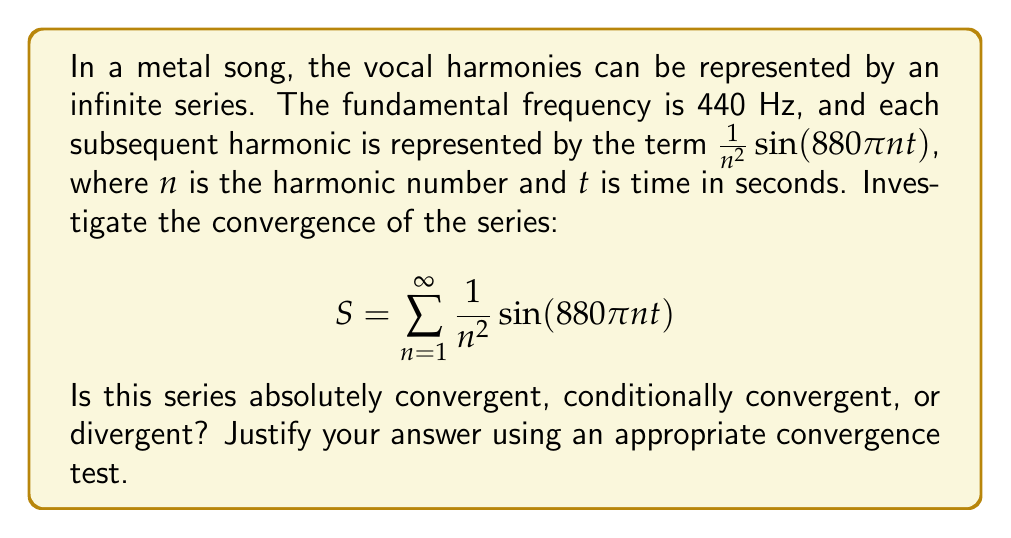Give your solution to this math problem. To investigate the convergence of this series, we'll use the following steps:

1) First, note that $\sin(880\pi nt)$ is bounded between -1 and 1 for all $n$ and $t$. Therefore, we can focus on the convergence of the series of the absolute values of the general term:

   $$\sum_{n=1}^{\infty} \left|\frac{1}{n^2}\sin(880\pi nt)\right| \leq \sum_{n=1}^{\infty} \frac{1}{n^2}$$

2) We recognize $\sum_{n=1}^{\infty} \frac{1}{n^2}$ as the p-series with $p=2$. We know that p-series converge for $p > 1$.

3) Since $2 > 1$, the series $\sum_{n=1}^{\infty} \frac{1}{n^2}$ converges. In fact, this is the famous Basel problem, and the sum is known to be $\frac{\pi^2}{6}$.

4) By the comparison test, if $\sum_{n=1}^{\infty} \frac{1}{n^2}$ converges, then $\sum_{n=1}^{\infty} \left|\frac{1}{n^2}\sin(880\pi nt)\right|$ also converges.

5) The convergence of $\sum_{n=1}^{\infty} \left|\frac{1}{n^2}\sin(880\pi nt)\right|$ implies that the original series $S = \sum_{n=1}^{\infty} \frac{1}{n^2}\sin(880\pi nt)$ is absolutely convergent.

Therefore, we can conclude that the series representing the vocal harmonies is absolutely convergent.
Answer: Absolutely convergent 